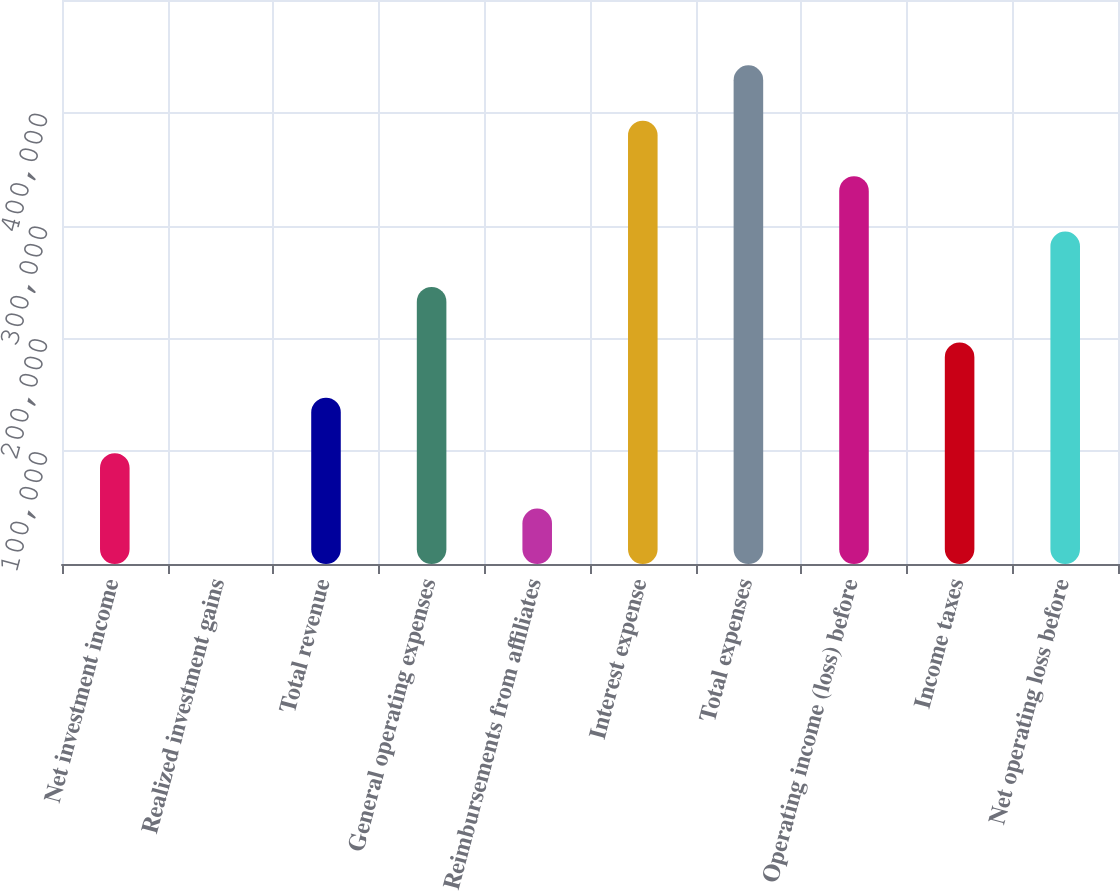<chart> <loc_0><loc_0><loc_500><loc_500><bar_chart><fcel>Net investment income<fcel>Realized investment gains<fcel>Total revenue<fcel>General operating expenses<fcel>Reimbursements from affiliates<fcel>Interest expense<fcel>Total expenses<fcel>Operating income (loss) before<fcel>Income taxes<fcel>Net operating loss before<nl><fcel>98239.5<fcel>4.12<fcel>147357<fcel>245593<fcel>49121.8<fcel>392946<fcel>442063<fcel>343828<fcel>196475<fcel>294710<nl></chart> 